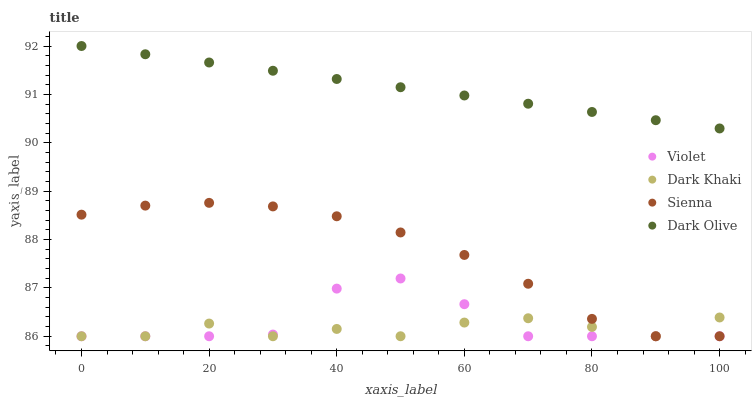Does Dark Khaki have the minimum area under the curve?
Answer yes or no. Yes. Does Dark Olive have the maximum area under the curve?
Answer yes or no. Yes. Does Sienna have the minimum area under the curve?
Answer yes or no. No. Does Sienna have the maximum area under the curve?
Answer yes or no. No. Is Dark Olive the smoothest?
Answer yes or no. Yes. Is Violet the roughest?
Answer yes or no. Yes. Is Sienna the smoothest?
Answer yes or no. No. Is Sienna the roughest?
Answer yes or no. No. Does Dark Khaki have the lowest value?
Answer yes or no. Yes. Does Dark Olive have the lowest value?
Answer yes or no. No. Does Dark Olive have the highest value?
Answer yes or no. Yes. Does Sienna have the highest value?
Answer yes or no. No. Is Dark Khaki less than Dark Olive?
Answer yes or no. Yes. Is Dark Olive greater than Dark Khaki?
Answer yes or no. Yes. Does Violet intersect Sienna?
Answer yes or no. Yes. Is Violet less than Sienna?
Answer yes or no. No. Is Violet greater than Sienna?
Answer yes or no. No. Does Dark Khaki intersect Dark Olive?
Answer yes or no. No. 